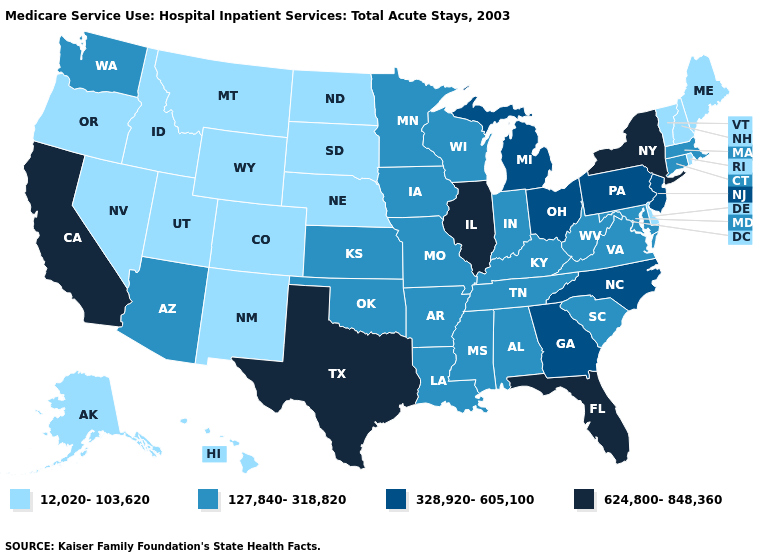What is the highest value in states that border Alabama?
Quick response, please. 624,800-848,360. Does Vermont have the highest value in the USA?
Give a very brief answer. No. Among the states that border Nebraska , which have the highest value?
Give a very brief answer. Iowa, Kansas, Missouri. Which states hav the highest value in the South?
Keep it brief. Florida, Texas. What is the lowest value in the MidWest?
Answer briefly. 12,020-103,620. Does Rhode Island have the highest value in the Northeast?
Concise answer only. No. Among the states that border Virginia , which have the highest value?
Be succinct. North Carolina. Does the first symbol in the legend represent the smallest category?
Quick response, please. Yes. Which states have the lowest value in the USA?
Short answer required. Alaska, Colorado, Delaware, Hawaii, Idaho, Maine, Montana, Nebraska, Nevada, New Hampshire, New Mexico, North Dakota, Oregon, Rhode Island, South Dakota, Utah, Vermont, Wyoming. Does Illinois have the highest value in the MidWest?
Write a very short answer. Yes. Among the states that border Arkansas , which have the highest value?
Short answer required. Texas. What is the lowest value in the USA?
Quick response, please. 12,020-103,620. Does New Jersey have the highest value in the Northeast?
Quick response, please. No. Does Illinois have the highest value in the MidWest?
Concise answer only. Yes. 